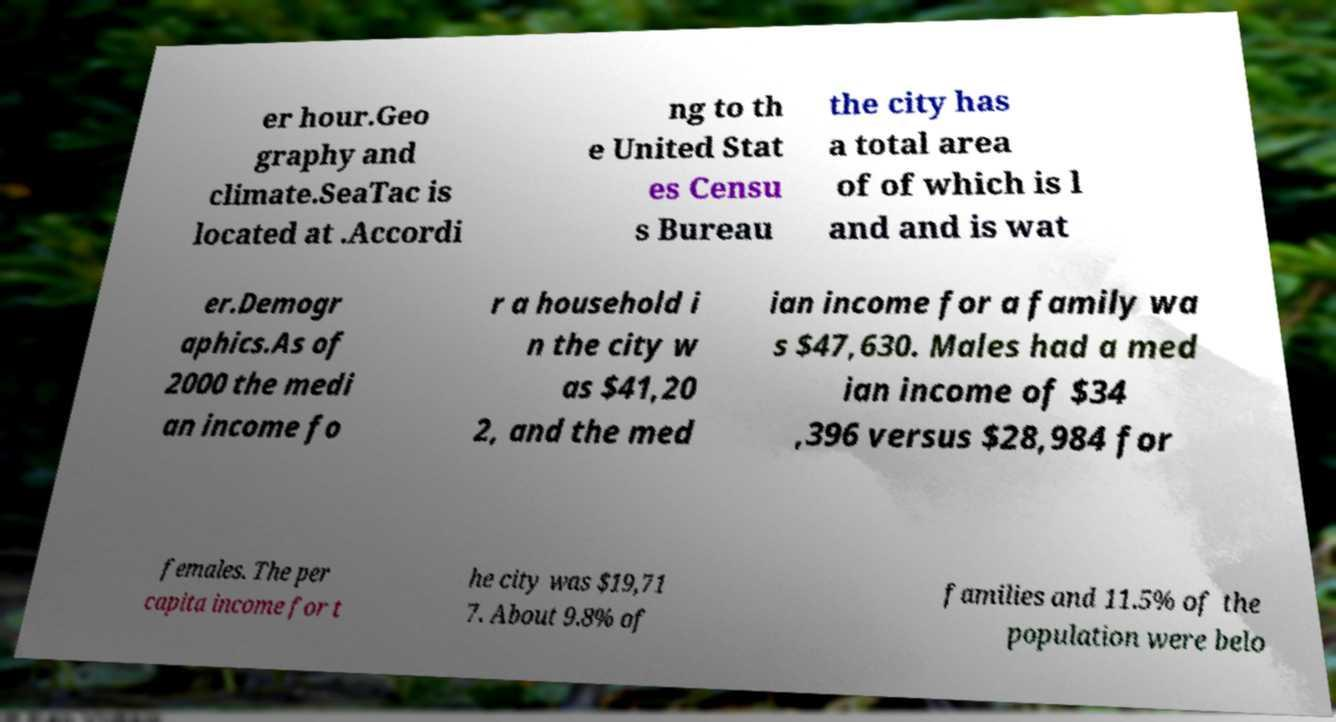Can you read and provide the text displayed in the image?This photo seems to have some interesting text. Can you extract and type it out for me? er hour.Geo graphy and climate.SeaTac is located at .Accordi ng to th e United Stat es Censu s Bureau the city has a total area of of which is l and and is wat er.Demogr aphics.As of 2000 the medi an income fo r a household i n the city w as $41,20 2, and the med ian income for a family wa s $47,630. Males had a med ian income of $34 ,396 versus $28,984 for females. The per capita income for t he city was $19,71 7. About 9.8% of families and 11.5% of the population were belo 